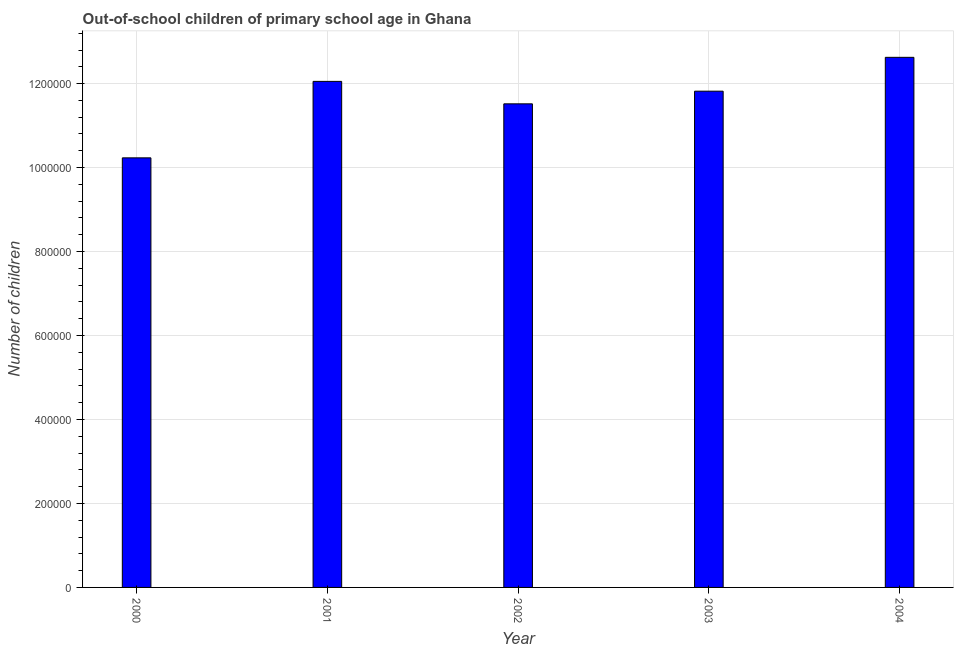Does the graph contain grids?
Your answer should be compact. Yes. What is the title of the graph?
Provide a succinct answer. Out-of-school children of primary school age in Ghana. What is the label or title of the X-axis?
Your answer should be compact. Year. What is the label or title of the Y-axis?
Give a very brief answer. Number of children. What is the number of out-of-school children in 2001?
Offer a terse response. 1.21e+06. Across all years, what is the maximum number of out-of-school children?
Your answer should be compact. 1.26e+06. Across all years, what is the minimum number of out-of-school children?
Your answer should be compact. 1.02e+06. In which year was the number of out-of-school children minimum?
Make the answer very short. 2000. What is the sum of the number of out-of-school children?
Your answer should be compact. 5.82e+06. What is the difference between the number of out-of-school children in 2000 and 2003?
Keep it short and to the point. -1.59e+05. What is the average number of out-of-school children per year?
Keep it short and to the point. 1.16e+06. What is the median number of out-of-school children?
Offer a very short reply. 1.18e+06. Do a majority of the years between 2002 and 2000 (inclusive) have number of out-of-school children greater than 480000 ?
Keep it short and to the point. Yes. What is the ratio of the number of out-of-school children in 2001 to that in 2002?
Make the answer very short. 1.05. Is the difference between the number of out-of-school children in 2000 and 2004 greater than the difference between any two years?
Offer a very short reply. Yes. What is the difference between the highest and the second highest number of out-of-school children?
Ensure brevity in your answer.  5.73e+04. What is the difference between the highest and the lowest number of out-of-school children?
Your answer should be very brief. 2.39e+05. In how many years, is the number of out-of-school children greater than the average number of out-of-school children taken over all years?
Provide a short and direct response. 3. Are all the bars in the graph horizontal?
Give a very brief answer. No. How many years are there in the graph?
Offer a very short reply. 5. Are the values on the major ticks of Y-axis written in scientific E-notation?
Your response must be concise. No. What is the Number of children in 2000?
Provide a short and direct response. 1.02e+06. What is the Number of children in 2001?
Make the answer very short. 1.21e+06. What is the Number of children in 2002?
Make the answer very short. 1.15e+06. What is the Number of children of 2003?
Make the answer very short. 1.18e+06. What is the Number of children in 2004?
Provide a succinct answer. 1.26e+06. What is the difference between the Number of children in 2000 and 2001?
Provide a succinct answer. -1.82e+05. What is the difference between the Number of children in 2000 and 2002?
Offer a terse response. -1.29e+05. What is the difference between the Number of children in 2000 and 2003?
Your response must be concise. -1.59e+05. What is the difference between the Number of children in 2000 and 2004?
Your answer should be compact. -2.39e+05. What is the difference between the Number of children in 2001 and 2002?
Ensure brevity in your answer.  5.35e+04. What is the difference between the Number of children in 2001 and 2003?
Your answer should be very brief. 2.33e+04. What is the difference between the Number of children in 2001 and 2004?
Provide a succinct answer. -5.73e+04. What is the difference between the Number of children in 2002 and 2003?
Your answer should be compact. -3.02e+04. What is the difference between the Number of children in 2002 and 2004?
Provide a short and direct response. -1.11e+05. What is the difference between the Number of children in 2003 and 2004?
Offer a very short reply. -8.06e+04. What is the ratio of the Number of children in 2000 to that in 2001?
Offer a very short reply. 0.85. What is the ratio of the Number of children in 2000 to that in 2002?
Your answer should be very brief. 0.89. What is the ratio of the Number of children in 2000 to that in 2003?
Give a very brief answer. 0.87. What is the ratio of the Number of children in 2000 to that in 2004?
Keep it short and to the point. 0.81. What is the ratio of the Number of children in 2001 to that in 2002?
Give a very brief answer. 1.05. What is the ratio of the Number of children in 2001 to that in 2003?
Your answer should be compact. 1.02. What is the ratio of the Number of children in 2001 to that in 2004?
Your response must be concise. 0.95. What is the ratio of the Number of children in 2002 to that in 2003?
Provide a succinct answer. 0.97. What is the ratio of the Number of children in 2002 to that in 2004?
Give a very brief answer. 0.91. What is the ratio of the Number of children in 2003 to that in 2004?
Your response must be concise. 0.94. 